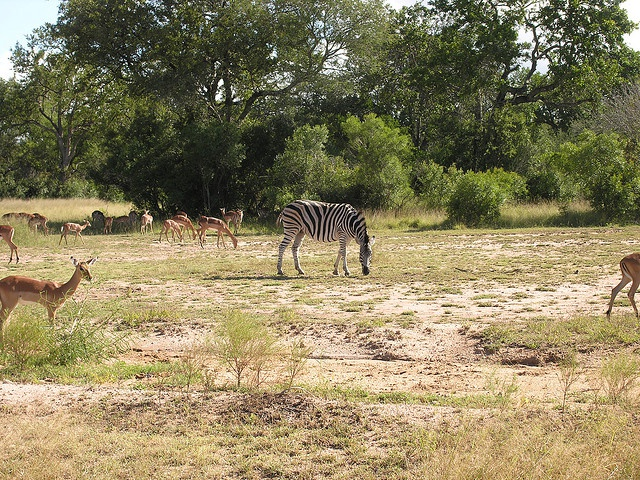Describe the objects in this image and their specific colors. I can see a zebra in white, black, gray, and darkgray tones in this image. 